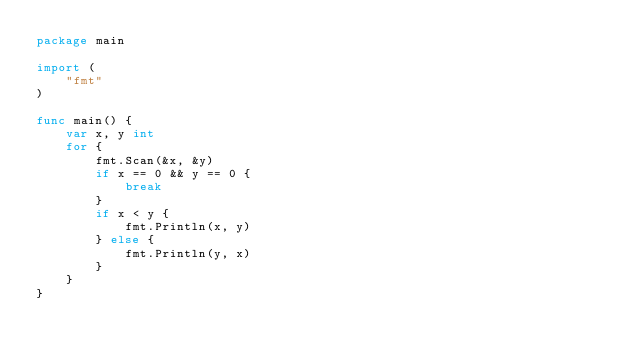Convert code to text. <code><loc_0><loc_0><loc_500><loc_500><_Go_>package main

import (
	"fmt"
)

func main() {
	var x, y int
	for {
		fmt.Scan(&x, &y)
		if x == 0 && y == 0 {
			break
		}
		if x < y {
			fmt.Println(x, y)
		} else {
			fmt.Println(y, x)
		}
	}
}

</code> 